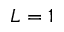Convert formula to latex. <formula><loc_0><loc_0><loc_500><loc_500>L = 1</formula> 